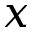Convert formula to latex. <formula><loc_0><loc_0><loc_500><loc_500>x</formula> 